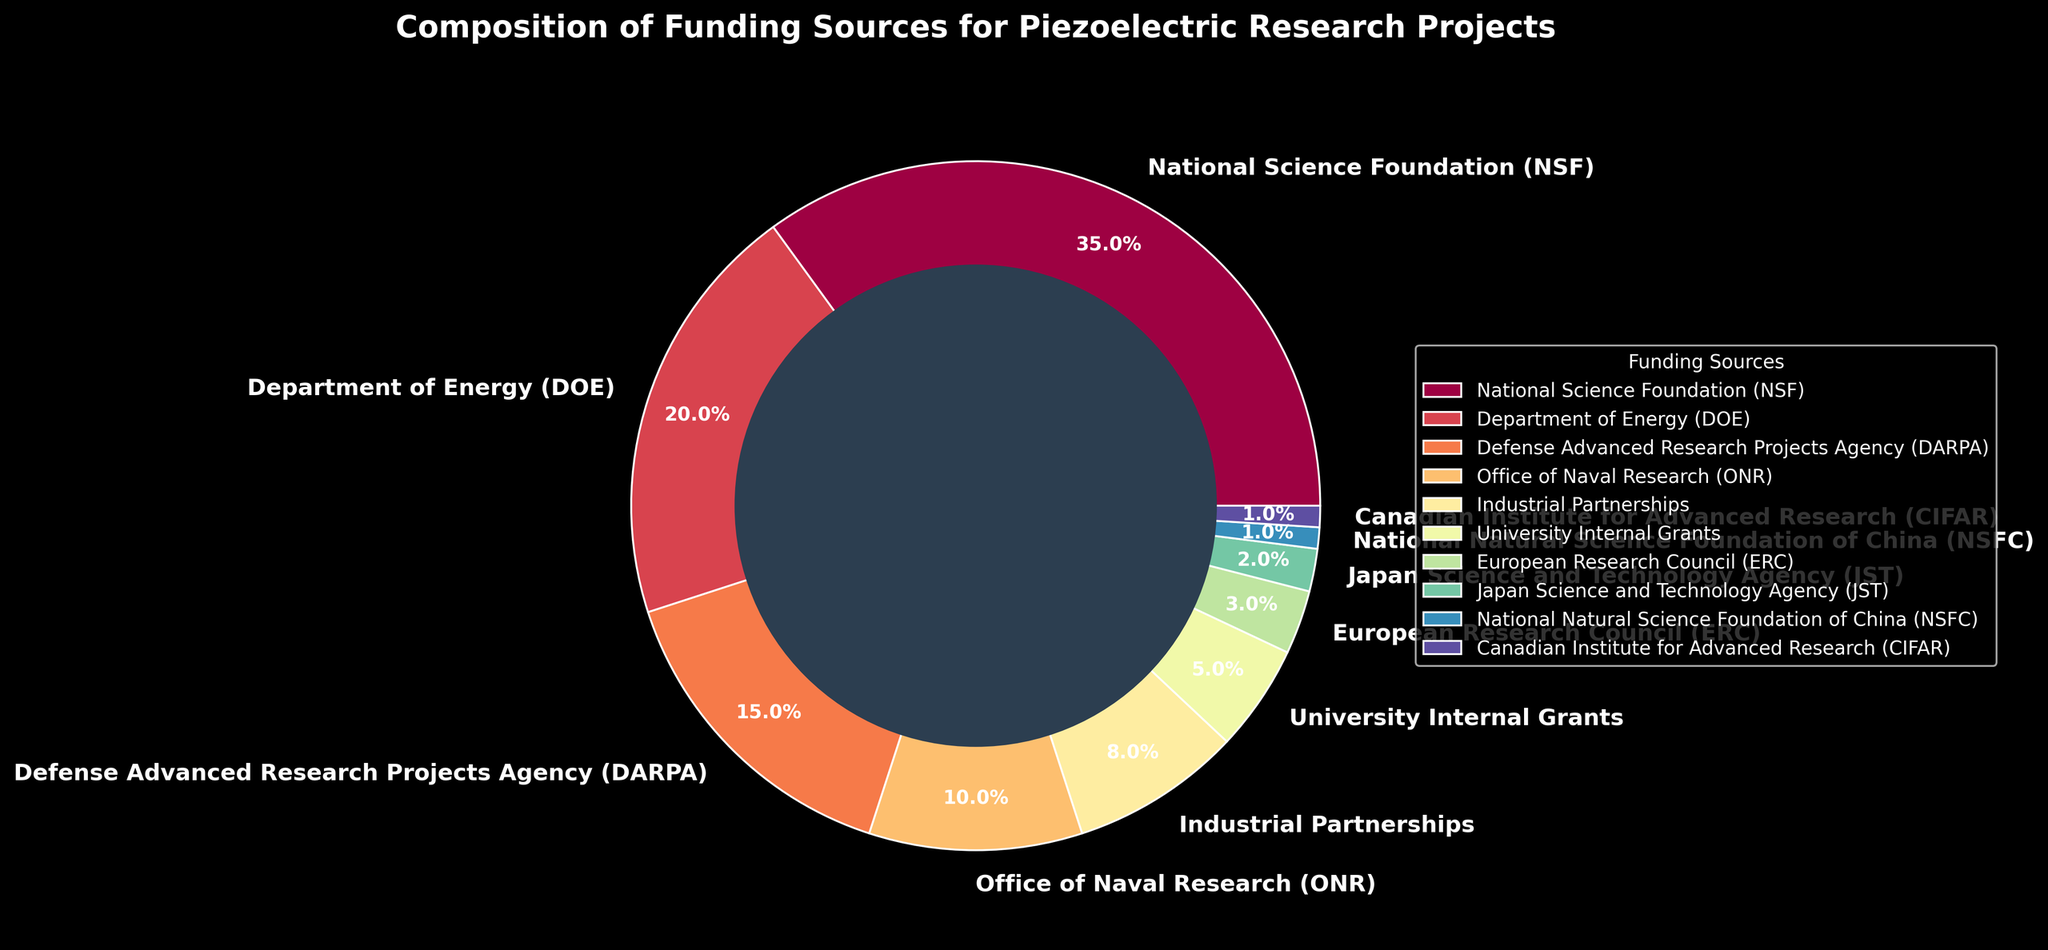What is the total percentage of funding from government agencies (NSF, DOE, DARPA, ONR)? Sum the percentages of the National Science Foundation (35%), Department of Energy (20%), Defense Advanced Research Projects Agency (15%), and Office of Naval Research (10%): 35% + 20% + 15% + 10% = 80%
Answer: 80% Which funding source provides the largest share of the funding? Identify the funding source with the highest percentage. The National Science Foundation has 35%, which is the highest among all sources listed
Answer: National Science Foundation (NSF) How much more funding does the DOE provide compared to Industrial Partnerships? Subtract the percentage of Industrial Partnerships (8%) from the Department of Energy (20%): 20% - 8% = 12%
Answer: 12% What is the combined percentage of funding from international sources (ERC, JST, NSFC, CIFAR)? Sum the percentages of the European Research Council (3%), Japan Science and Technology Agency (2%), National Natural Science Foundation of China (1%), and Canadian Institute for Advanced Research (1%): 3% + 2% + 1% + 1% = 7%
Answer: 7% Among NSF and DOE, which one contributes more to piezoelectric research funding, and by how much? Compare the contributions of NSF (35%) and DOE (20%). NSF contributes more. Subtract DOE's percentage from NSF's: 35% - 20% = 15%
Answer: NSF contributes 15% more What percentage of the total funding is provided by University Internal Grants and Industrial Partnerships combined? Sum the percentages of University Internal Grants (5%) and Industrial Partnerships (8%): 5% + 8% = 13%
Answer: 13% Which funding sources contribute 10% or less to the total funding? Identify the funding sources with percentages 10% or less. Relevant sources are ONR (10%), Industrial Partnerships (8%), University Internal Grants (5%), ERC (3%), JST (2%), NSFC (1%), and CIFAR (1%)
Answer: ONR, Industrial Partnerships, University Internal Grants, ERC, JST, NSFC, CIFAR What is the difference in funding percentage between the largest and smallest contributors? Identify the largest contributor (NSF at 35%) and the smallest contributors (NSFC and CIFAR at 1% each). Subtract the smallest percentage from the largest: 35% - 1% = 34%
Answer: 34% How do Industrial Partnerships compare with the Office of Naval Research in terms of funding percentage? Compare the funding percentages of Industrial Partnerships (8%) and Office of Naval Research (10%): 10% > 8%
Answer: The Office of Naval Research contributes 2% more than Industrial Partnerships If funding from the European Research Council and Japan Science and Technology Agency was doubled, what would be their combined new percentage? Double the percentages of both ERC (3%) and JST (2%), then sum the new values: (3% * 2) + (2% * 2) = 6% + 4% = 10%
Answer: 10% 